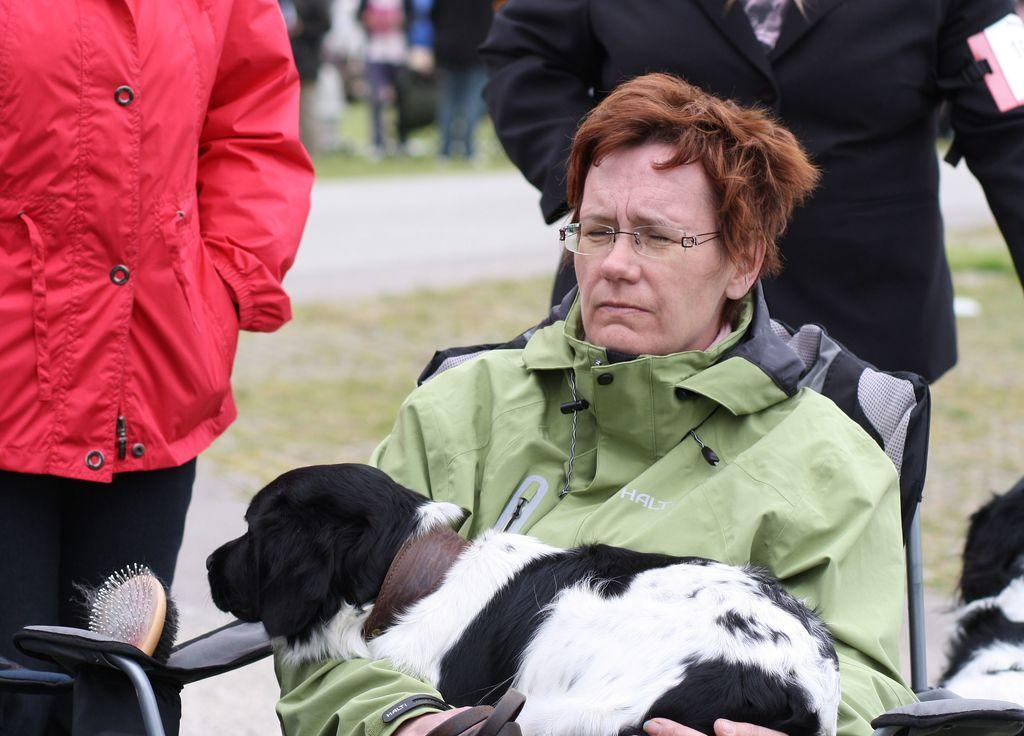Who is the main subject in the image? There is a woman in the image. What is the woman doing in the image? The woman is sitting in a chair and holding a dog in her hands. Are there any other people in the image? Yes, there are people standing behind the woman. Can you tell me how many rivers are visible in the image? There are no rivers visible in the image. What type of mitten is the woman wearing on her hands? The woman is not wearing any mittens in the image; she is holding a dog in her hands. 